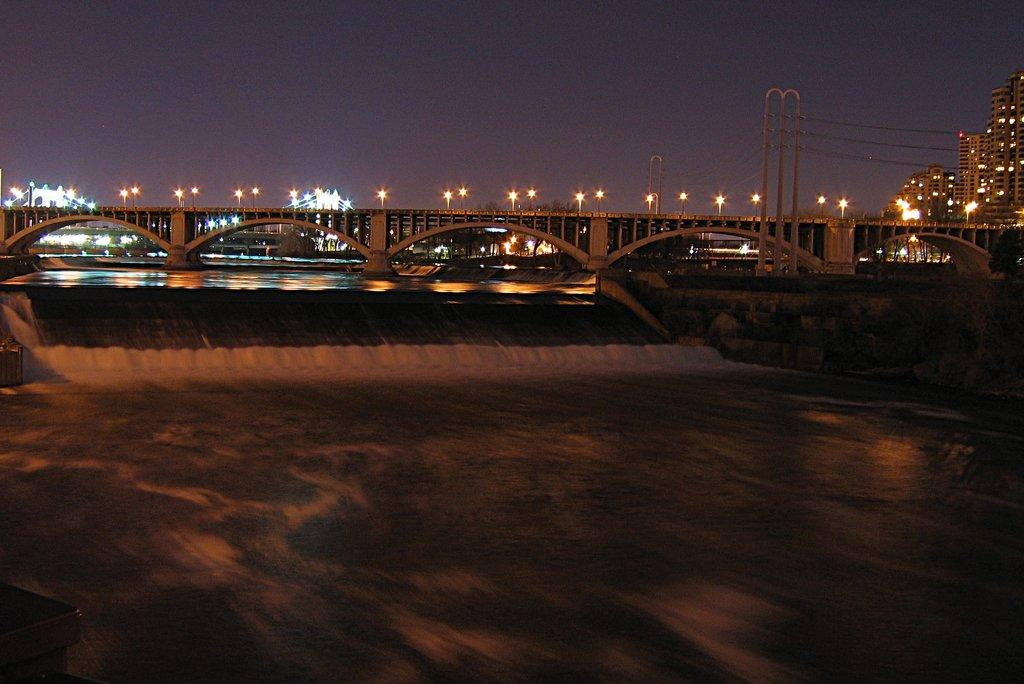What type of structure is present in the image? There is a bridge in the image. What can be seen illuminating the scene in the image? There are lights in the image. What type of man-made structures are visible in the image? There are buildings in the image. What type of barrier is present in the image? There is a wall in the image. What is visible in the background of the image? The sky is visible in the background of the image. How many brothers are depicted in the image? There are no brothers present in the image. What flavor of ice cream is being enjoyed by the brothers in the image? There are no brothers or ice cream present in the image. 